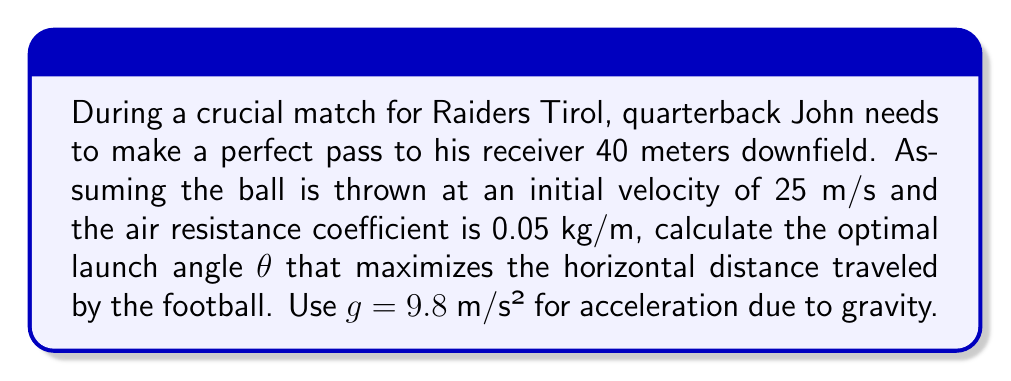Could you help me with this problem? To solve this problem, we need to consider the equations of motion for a projectile with air resistance. The optimal angle for maximum range with air resistance is slightly less than 45° (which would be the case without air resistance).

1) First, let's define our variables:
   $v_0$ = 25 m/s (initial velocity)
   $k$ = 0.05 kg/m (air resistance coefficient)
   $m$ = 0.4 kg (approximate mass of an American football)
   $g$ = 9.8 m/s² (acceleration due to gravity)

2) The equation for the horizontal distance traveled (range) with air resistance is:

   $$R = \frac{m}{k} \ln\left(1 + \frac{2kv_0^2\sin\theta\cos\theta}{mg}\right)$$

3) To find the optimal angle, we need to maximize this function. We can do this by differentiating R with respect to θ and setting it to zero:

   $$\frac{dR}{d\theta} = \frac{mv_0^2}{kg}\cdot\frac{2\cos^2\theta - 2\sin^2\theta}{1 + \frac{2kv_0^2\sin\theta\cos\theta}{mg}} = 0$$

4) Solving this equation:

   $2\cos^2\theta - 2\sin^2\theta = 0$
   $\cos^2\theta = \sin^2\theta$
   $\cos\theta = \sin\theta$

5) This is satisfied when $\theta = 45°$. However, due to air resistance, the actual optimal angle will be slightly less than this.

6) To find the exact angle, we can use numerical methods or approximations. A good approximation for the optimal angle with air resistance is:

   $$\theta_{optimal} \approx 45° - \frac{45°}{2\pi}\cdot\frac{kv_0}{mg}$$

7) Plugging in our values:

   $$\theta_{optimal} \approx 45° - \frac{45°}{2\pi}\cdot\frac{0.05 \cdot 25}{0.4 \cdot 9.8} \approx 43.7°$$

This angle will give John the maximum horizontal distance for his pass, considering air resistance.
Answer: The optimal launch angle for John's pass is approximately 43.7°. 